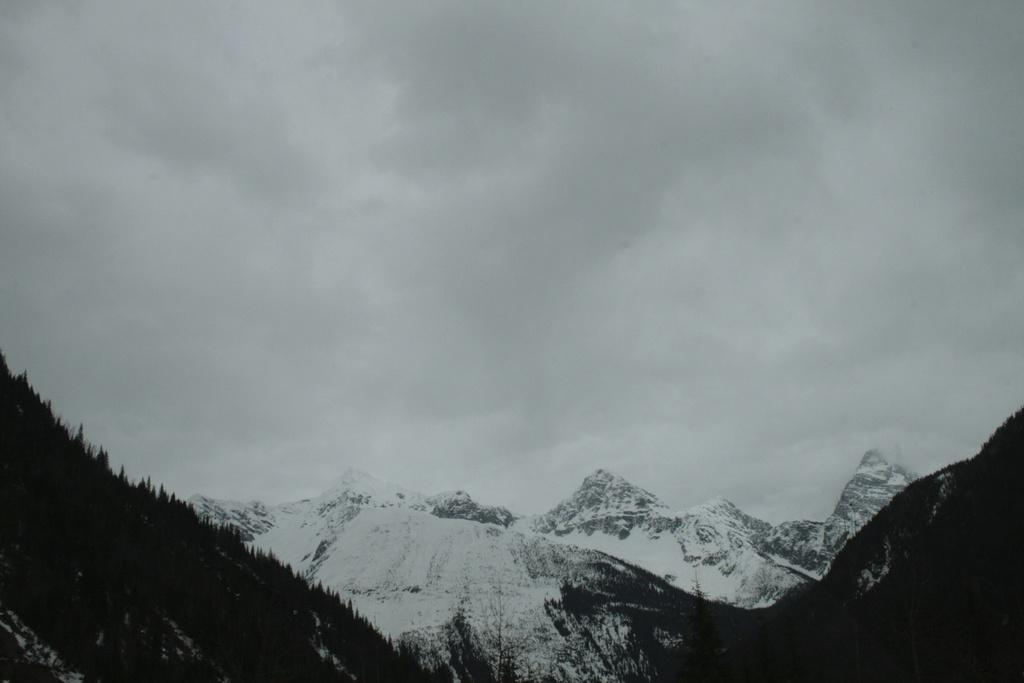What type of natural formation can be seen in the image? There are snow mountains in the image. What can be found on the mountain on the left side? There are trees on the mountain on the left side. What is visible at the top of the image? The sky is visible at the top of the image. What can be seen in the sky? Clouds are present in the sky. What grade did the beast receive on its snow mountain climbing test in the image? There is no beast or any indication of a test in the image; it simply shows snow mountains with trees and clouds. 